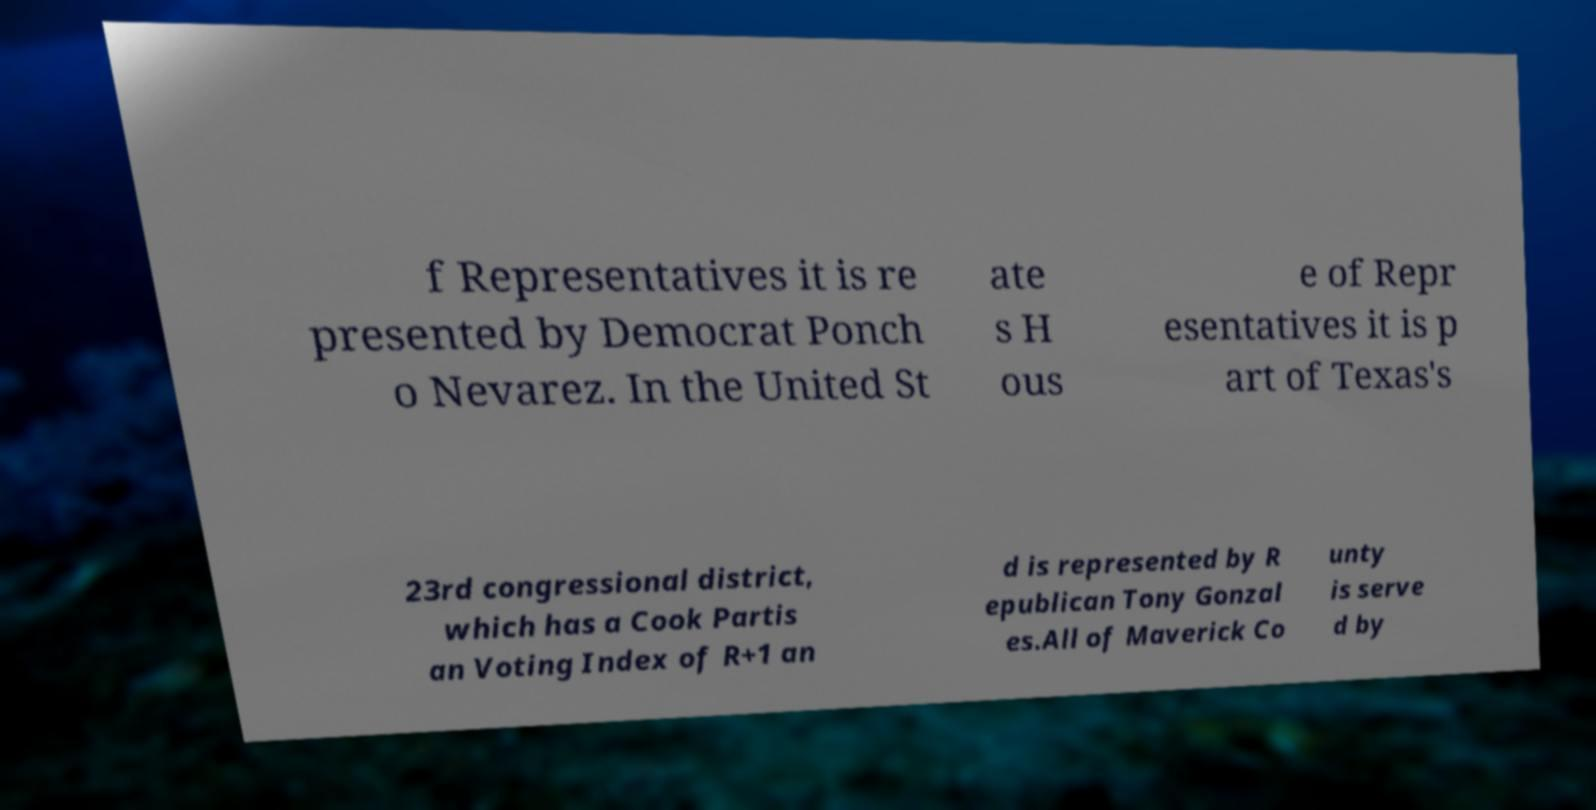Could you assist in decoding the text presented in this image and type it out clearly? f Representatives it is re presented by Democrat Ponch o Nevarez. In the United St ate s H ous e of Repr esentatives it is p art of Texas's 23rd congressional district, which has a Cook Partis an Voting Index of R+1 an d is represented by R epublican Tony Gonzal es.All of Maverick Co unty is serve d by 